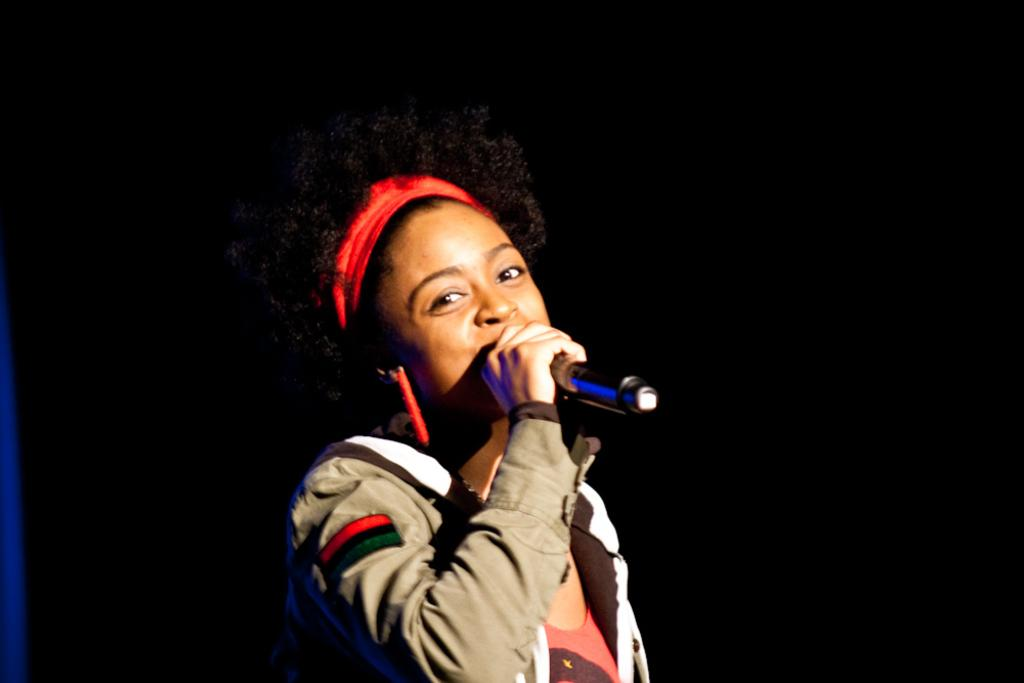Who is present in the image? There is a woman present in the image. What is the woman wearing on her upper body? The woman is wearing a jacket and an orange color t-shirt. What accessories is the woman wearing? The woman is wearing earrings and a hair band. What is the woman holding in her hand? The woman is holding a mic in her hand. Can you see any tigers, cows, or rays in the image? No, there are no tigers, cows, or rays present in the image. 